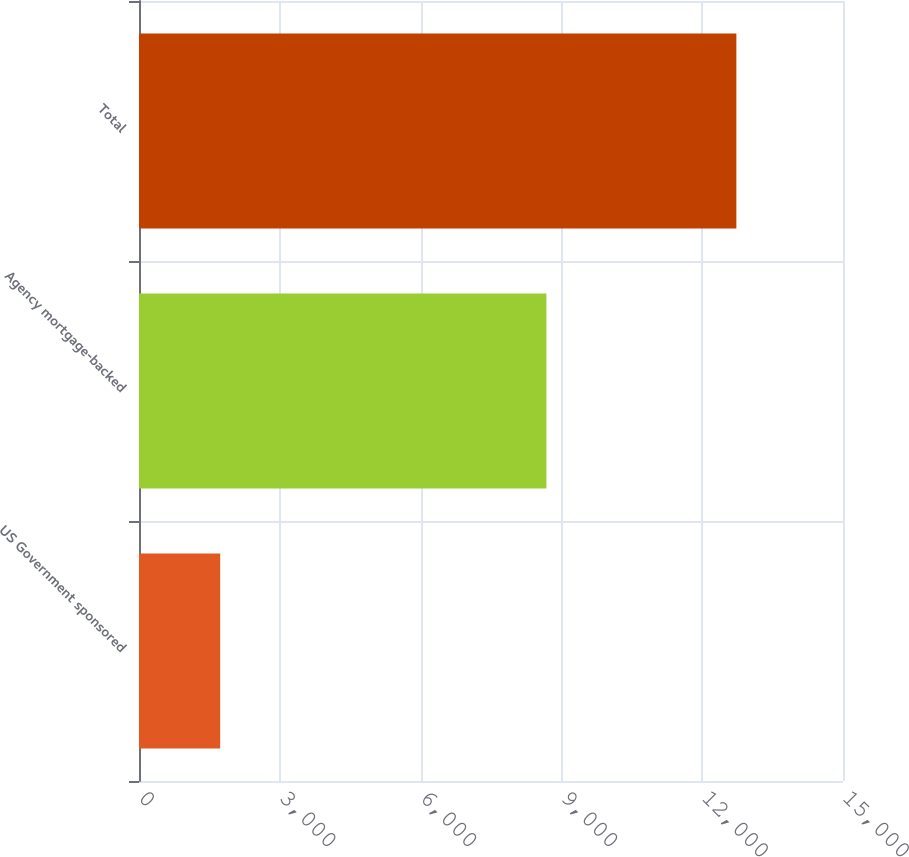Convert chart to OTSL. <chart><loc_0><loc_0><loc_500><loc_500><bar_chart><fcel>US Government sponsored<fcel>Agency mortgage-backed<fcel>Total<nl><fcel>1730<fcel>8681<fcel>12728<nl></chart> 